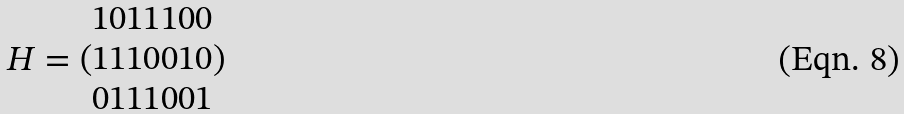<formula> <loc_0><loc_0><loc_500><loc_500>H = ( \begin{matrix} 1 0 1 1 1 0 0 \\ 1 1 1 0 0 1 0 \\ 0 1 1 1 0 0 1 \end{matrix} )</formula> 